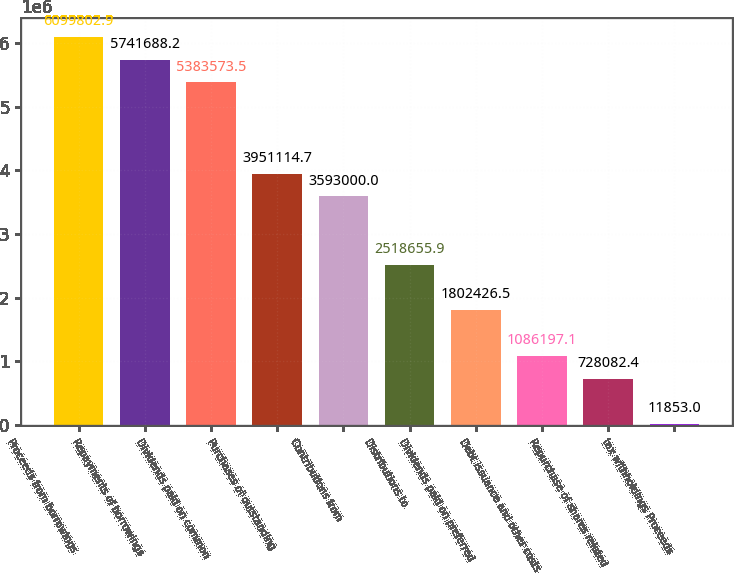Convert chart to OTSL. <chart><loc_0><loc_0><loc_500><loc_500><bar_chart><fcel>Proceeds from borrowings<fcel>Repayments of borrowings<fcel>Dividends paid on common<fcel>Purchases of outstanding<fcel>Contributions from<fcel>Distributions to<fcel>Dividends paid on preferred<fcel>Debt issuance and other costs<fcel>Repurchase of shares related<fcel>tax withholdings Proceeds<nl><fcel>6.0998e+06<fcel>5.74169e+06<fcel>5.38357e+06<fcel>3.95111e+06<fcel>3.593e+06<fcel>2.51866e+06<fcel>1.80243e+06<fcel>1.0862e+06<fcel>728082<fcel>11853<nl></chart> 